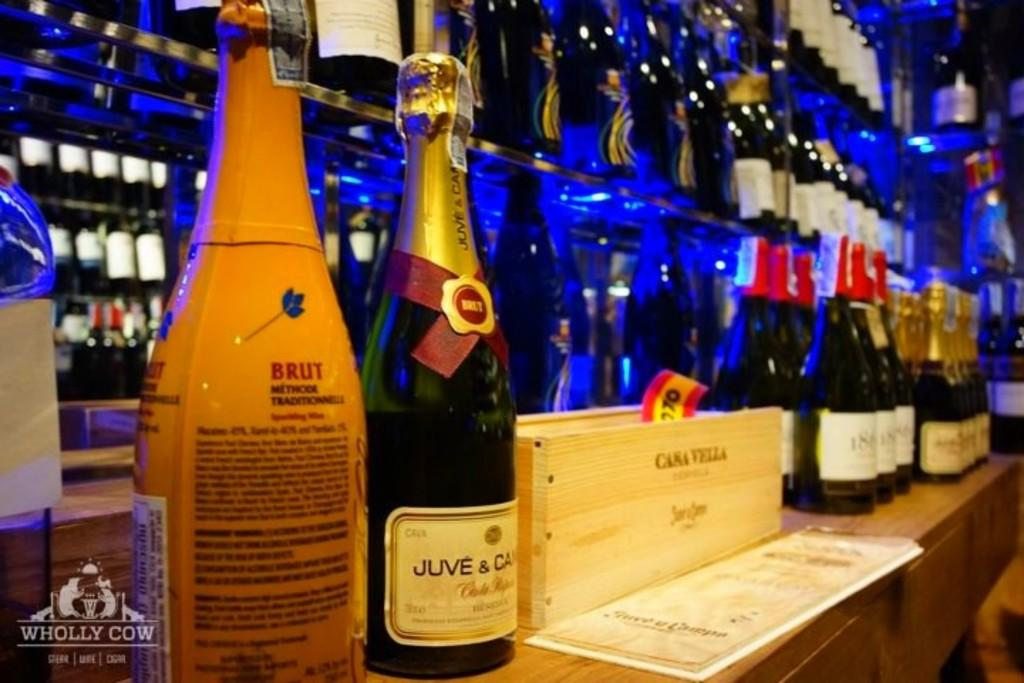<image>
Summarize the visual content of the image. Wine bottles on a counter from Juve & CAsa Valla. 